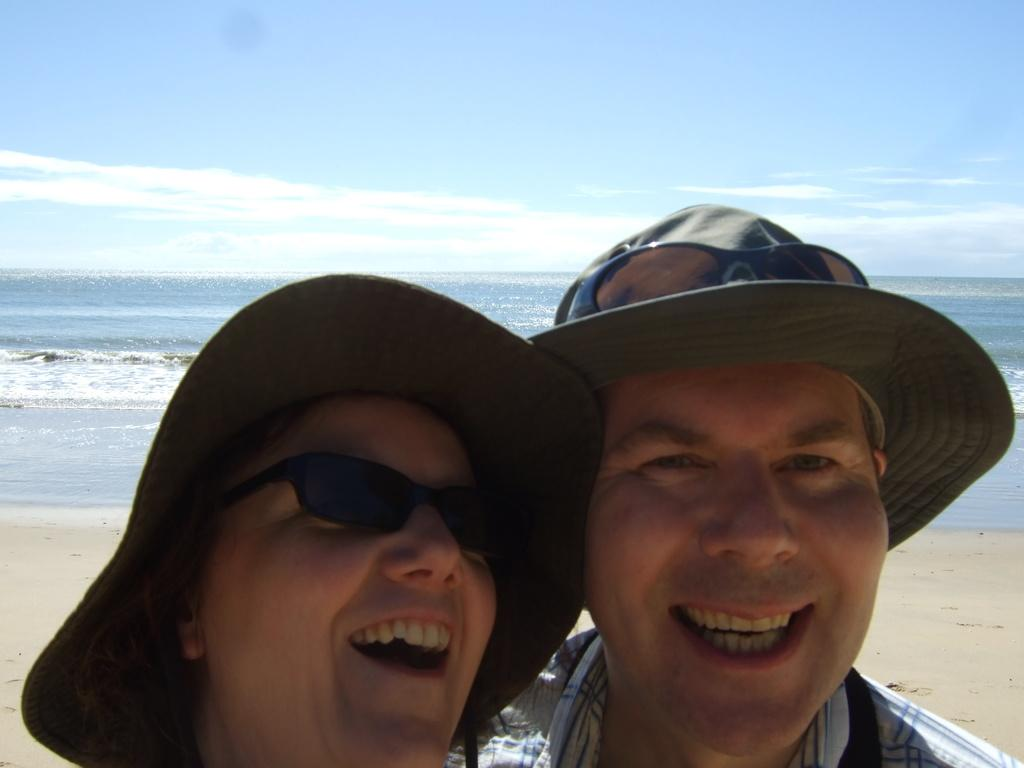Who is present in the image? There is a man and a woman in the image. What are the man and woman wearing on their heads? Both the man and woman are wearing hats. How are the man and woman positioned in the image? The man and woman are standing together. Where is the image set? The image is set at a beach. What is the facial expression of the man and woman? The man and woman are smiling. What type of attraction can be seen in the background of the image? There is no attraction visible in the background of the image; it is set at a beach. Can you tell me how many goats are present in the image? There are no goats present in the image; it features a man and a woman wearing hats and standing together at a beach. 